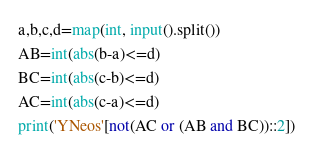<code> <loc_0><loc_0><loc_500><loc_500><_Python_>a,b,c,d=map(int, input().split())
AB=int(abs(b-a)<=d)
BC=int(abs(c-b)<=d)
AC=int(abs(c-a)<=d)
print('YNeos'[not(AC or (AB and BC))::2])</code> 